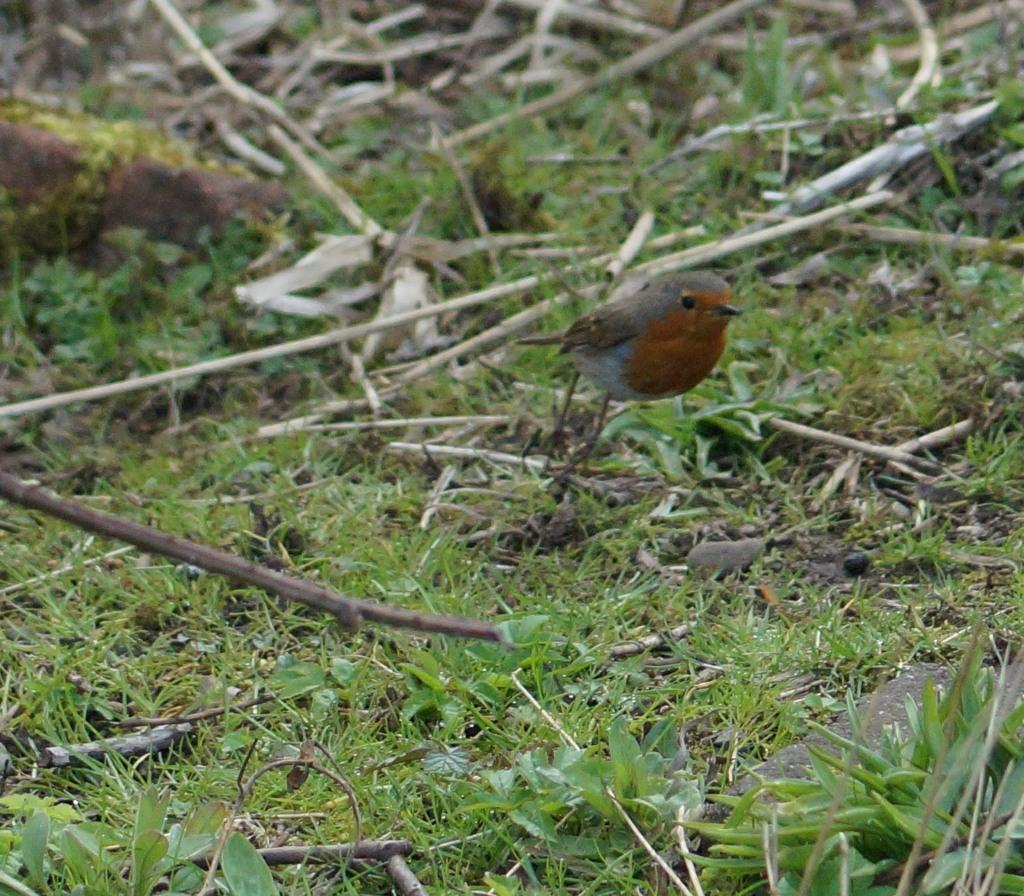What type of animal can be seen in the picture? There is a bird in the picture. Where is the bird located in the picture? The bird is on the grass. What type of vegetation is present in the picture? There is grass and plants in the picture. What other objects can be seen in the picture? There are sticks in the picture. What type of fuel is the bird using to fly in the picture? The bird is not flying in the picture, and therefore it is not using any fuel. What liquid can be seen in the picture? There is no liquid present in the picture. 